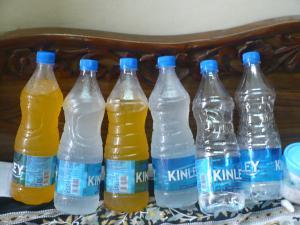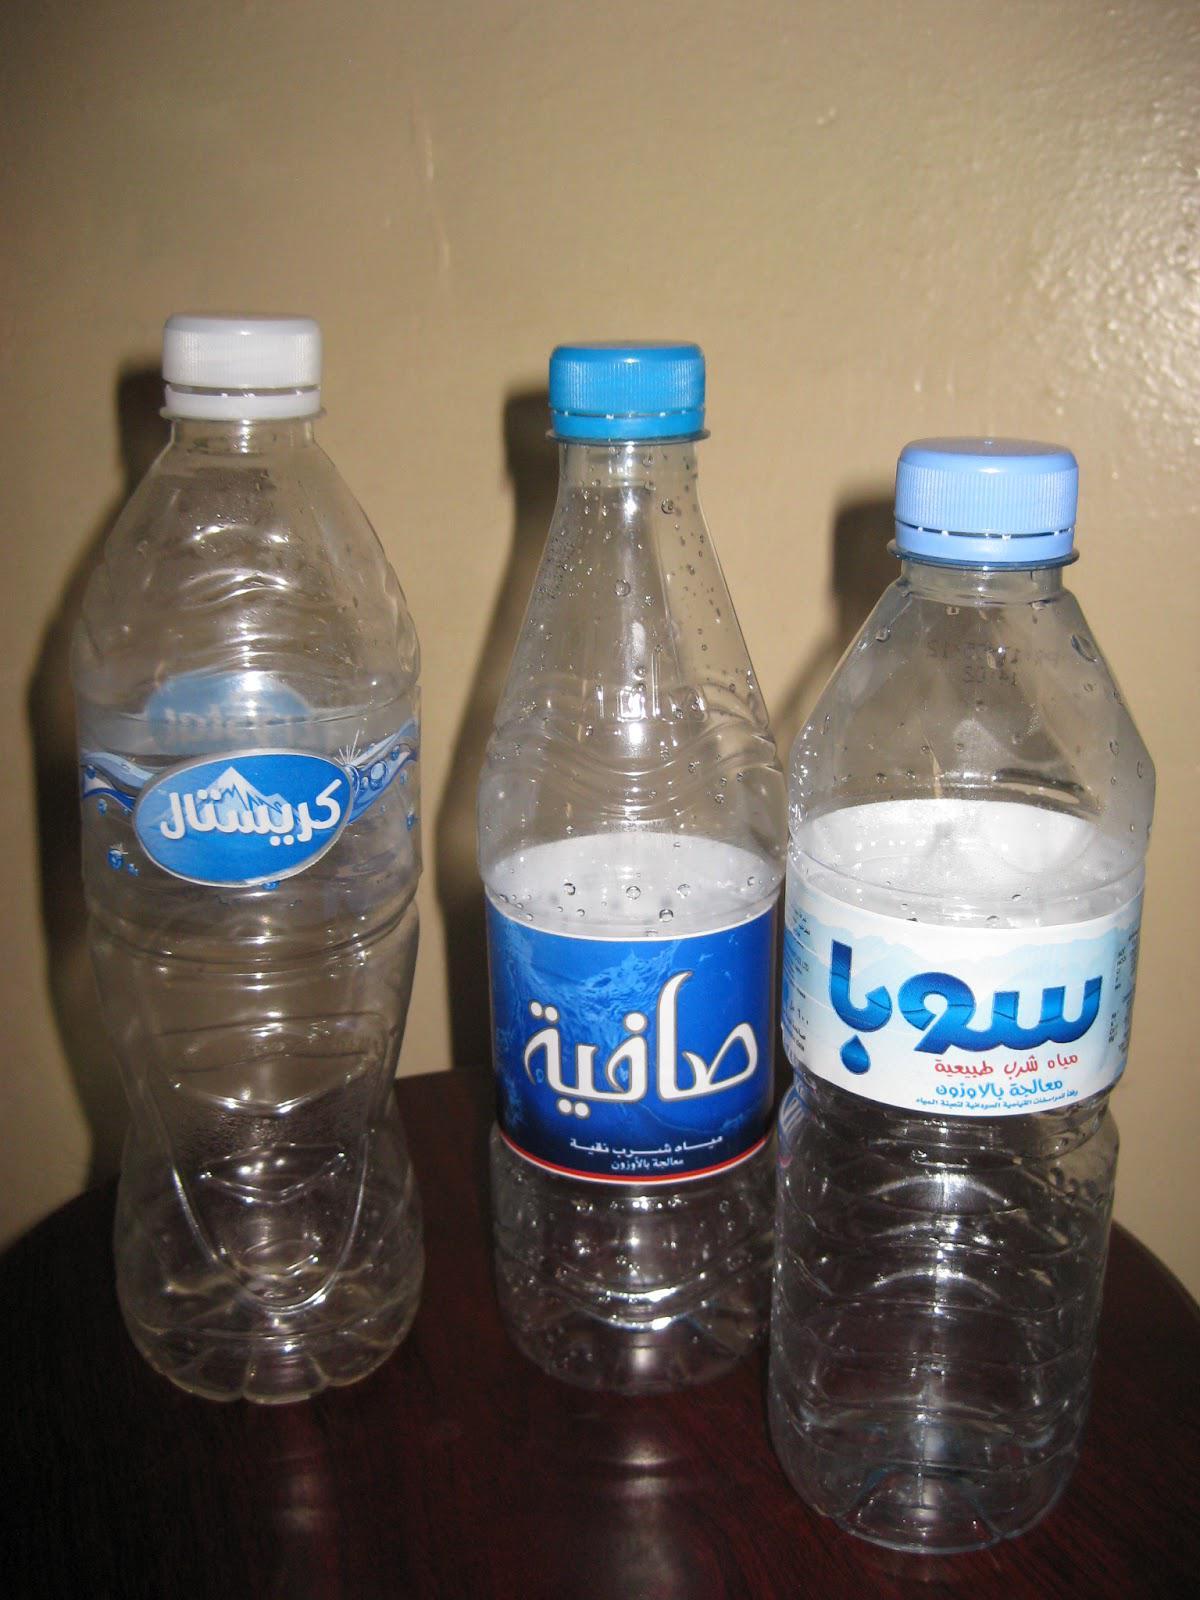The first image is the image on the left, the second image is the image on the right. For the images shown, is this caption "At least four bottles in the image on the left side have blue lids." true? Answer yes or no. Yes. 